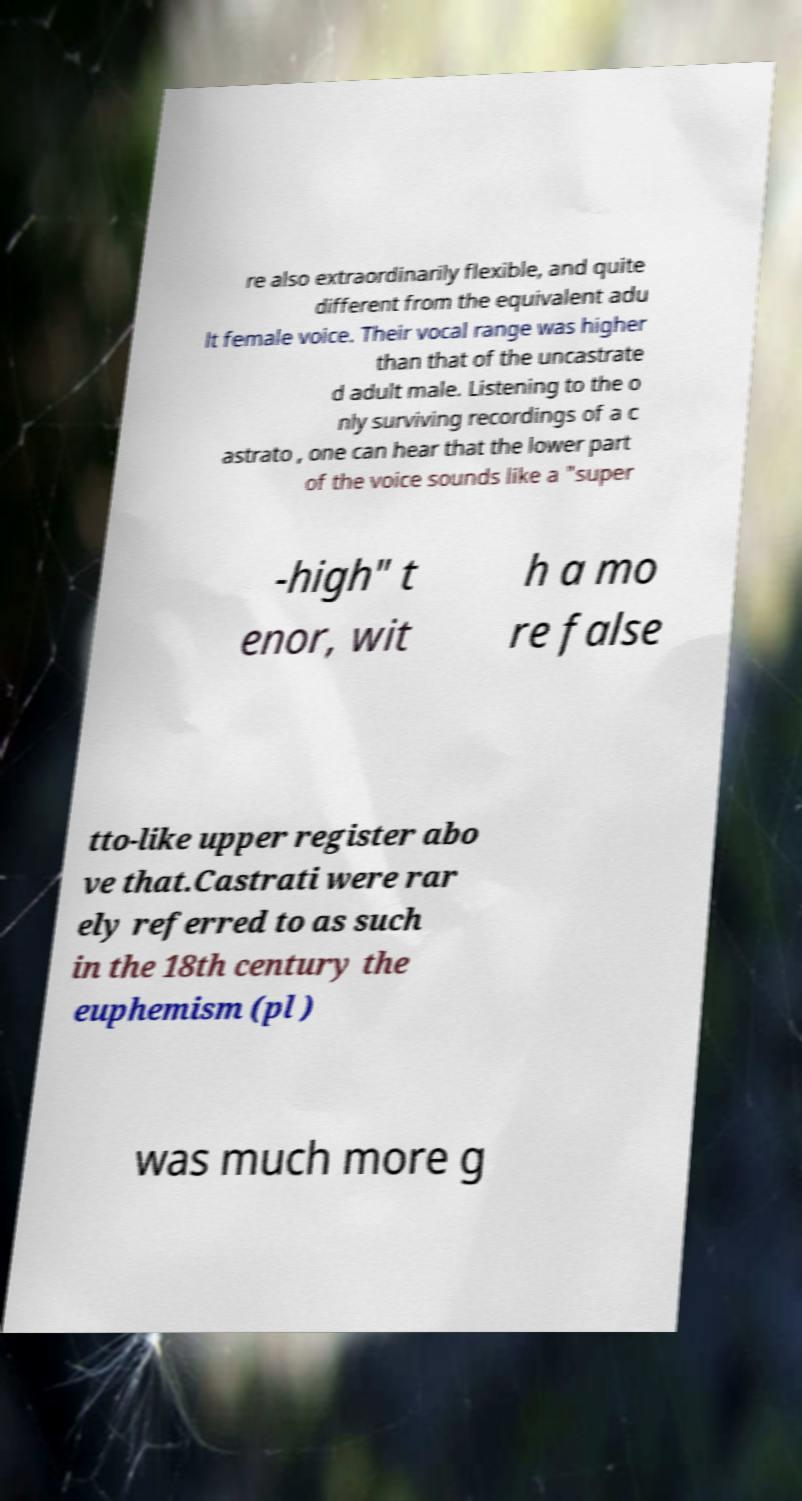There's text embedded in this image that I need extracted. Can you transcribe it verbatim? re also extraordinarily flexible, and quite different from the equivalent adu lt female voice. Their vocal range was higher than that of the uncastrate d adult male. Listening to the o nly surviving recordings of a c astrato , one can hear that the lower part of the voice sounds like a "super -high" t enor, wit h a mo re false tto-like upper register abo ve that.Castrati were rar ely referred to as such in the 18th century the euphemism (pl ) was much more g 